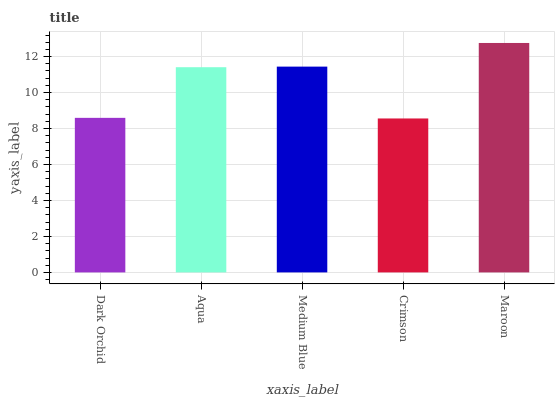Is Aqua the minimum?
Answer yes or no. No. Is Aqua the maximum?
Answer yes or no. No. Is Aqua greater than Dark Orchid?
Answer yes or no. Yes. Is Dark Orchid less than Aqua?
Answer yes or no. Yes. Is Dark Orchid greater than Aqua?
Answer yes or no. No. Is Aqua less than Dark Orchid?
Answer yes or no. No. Is Aqua the high median?
Answer yes or no. Yes. Is Aqua the low median?
Answer yes or no. Yes. Is Crimson the high median?
Answer yes or no. No. Is Crimson the low median?
Answer yes or no. No. 